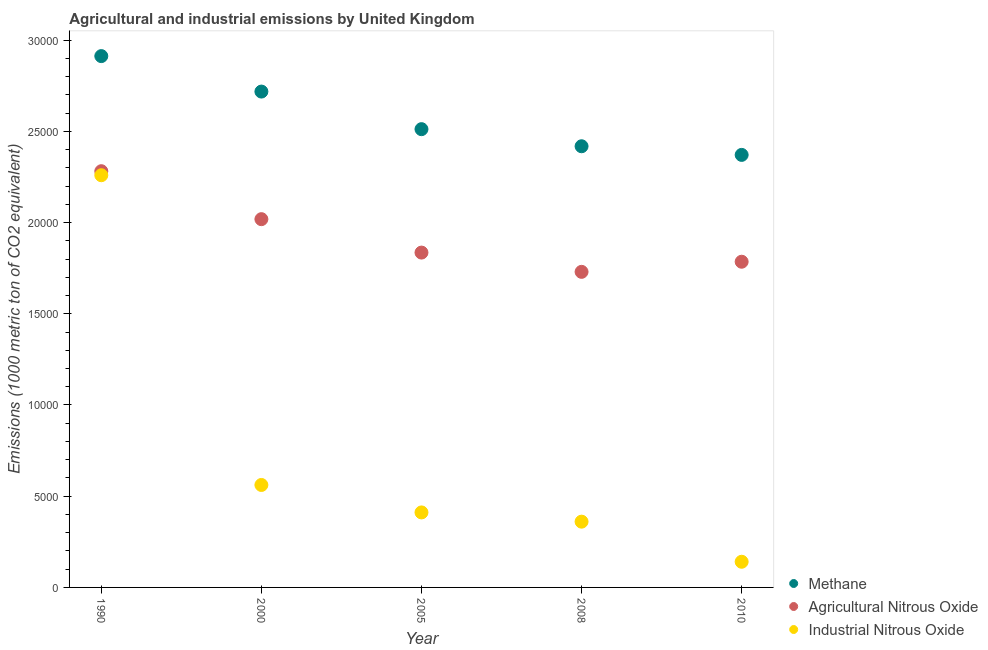What is the amount of methane emissions in 2005?
Give a very brief answer. 2.51e+04. Across all years, what is the maximum amount of methane emissions?
Provide a short and direct response. 2.91e+04. Across all years, what is the minimum amount of methane emissions?
Your answer should be very brief. 2.37e+04. What is the total amount of methane emissions in the graph?
Your answer should be compact. 1.29e+05. What is the difference between the amount of methane emissions in 1990 and that in 2008?
Ensure brevity in your answer.  4941.2. What is the difference between the amount of methane emissions in 2010 and the amount of industrial nitrous oxide emissions in 1990?
Your answer should be very brief. 1114.8. What is the average amount of agricultural nitrous oxide emissions per year?
Your answer should be compact. 1.93e+04. In the year 2000, what is the difference between the amount of industrial nitrous oxide emissions and amount of methane emissions?
Make the answer very short. -2.16e+04. In how many years, is the amount of industrial nitrous oxide emissions greater than 3000 metric ton?
Your answer should be compact. 4. What is the ratio of the amount of industrial nitrous oxide emissions in 2008 to that in 2010?
Offer a terse response. 2.56. Is the amount of agricultural nitrous oxide emissions in 2005 less than that in 2010?
Ensure brevity in your answer.  No. Is the difference between the amount of industrial nitrous oxide emissions in 2000 and 2008 greater than the difference between the amount of methane emissions in 2000 and 2008?
Keep it short and to the point. No. What is the difference between the highest and the second highest amount of agricultural nitrous oxide emissions?
Your response must be concise. 2628.9. What is the difference between the highest and the lowest amount of methane emissions?
Give a very brief answer. 5414.5. Is the sum of the amount of industrial nitrous oxide emissions in 2005 and 2010 greater than the maximum amount of agricultural nitrous oxide emissions across all years?
Offer a terse response. No. Is it the case that in every year, the sum of the amount of methane emissions and amount of agricultural nitrous oxide emissions is greater than the amount of industrial nitrous oxide emissions?
Your response must be concise. Yes. Does the amount of methane emissions monotonically increase over the years?
Offer a terse response. No. Is the amount of methane emissions strictly greater than the amount of industrial nitrous oxide emissions over the years?
Your answer should be very brief. Yes. Is the amount of methane emissions strictly less than the amount of industrial nitrous oxide emissions over the years?
Your answer should be very brief. No. How many dotlines are there?
Provide a succinct answer. 3. How many years are there in the graph?
Keep it short and to the point. 5. What is the difference between two consecutive major ticks on the Y-axis?
Provide a short and direct response. 5000. Does the graph contain any zero values?
Your answer should be compact. No. How many legend labels are there?
Make the answer very short. 3. What is the title of the graph?
Ensure brevity in your answer.  Agricultural and industrial emissions by United Kingdom. What is the label or title of the X-axis?
Offer a very short reply. Year. What is the label or title of the Y-axis?
Provide a short and direct response. Emissions (1000 metric ton of CO2 equivalent). What is the Emissions (1000 metric ton of CO2 equivalent) in Methane in 1990?
Your answer should be compact. 2.91e+04. What is the Emissions (1000 metric ton of CO2 equivalent) of Agricultural Nitrous Oxide in 1990?
Offer a terse response. 2.28e+04. What is the Emissions (1000 metric ton of CO2 equivalent) in Industrial Nitrous Oxide in 1990?
Offer a very short reply. 2.26e+04. What is the Emissions (1000 metric ton of CO2 equivalent) in Methane in 2000?
Ensure brevity in your answer.  2.72e+04. What is the Emissions (1000 metric ton of CO2 equivalent) of Agricultural Nitrous Oxide in 2000?
Offer a terse response. 2.02e+04. What is the Emissions (1000 metric ton of CO2 equivalent) of Industrial Nitrous Oxide in 2000?
Ensure brevity in your answer.  5616. What is the Emissions (1000 metric ton of CO2 equivalent) of Methane in 2005?
Provide a succinct answer. 2.51e+04. What is the Emissions (1000 metric ton of CO2 equivalent) of Agricultural Nitrous Oxide in 2005?
Your response must be concise. 1.84e+04. What is the Emissions (1000 metric ton of CO2 equivalent) in Industrial Nitrous Oxide in 2005?
Your response must be concise. 4111.2. What is the Emissions (1000 metric ton of CO2 equivalent) in Methane in 2008?
Your answer should be compact. 2.42e+04. What is the Emissions (1000 metric ton of CO2 equivalent) of Agricultural Nitrous Oxide in 2008?
Offer a terse response. 1.73e+04. What is the Emissions (1000 metric ton of CO2 equivalent) in Industrial Nitrous Oxide in 2008?
Provide a succinct answer. 3604.6. What is the Emissions (1000 metric ton of CO2 equivalent) in Methane in 2010?
Your answer should be compact. 2.37e+04. What is the Emissions (1000 metric ton of CO2 equivalent) of Agricultural Nitrous Oxide in 2010?
Your answer should be very brief. 1.79e+04. What is the Emissions (1000 metric ton of CO2 equivalent) in Industrial Nitrous Oxide in 2010?
Your answer should be very brief. 1406.6. Across all years, what is the maximum Emissions (1000 metric ton of CO2 equivalent) in Methane?
Your response must be concise. 2.91e+04. Across all years, what is the maximum Emissions (1000 metric ton of CO2 equivalent) in Agricultural Nitrous Oxide?
Your answer should be compact. 2.28e+04. Across all years, what is the maximum Emissions (1000 metric ton of CO2 equivalent) of Industrial Nitrous Oxide?
Offer a very short reply. 2.26e+04. Across all years, what is the minimum Emissions (1000 metric ton of CO2 equivalent) of Methane?
Give a very brief answer. 2.37e+04. Across all years, what is the minimum Emissions (1000 metric ton of CO2 equivalent) of Agricultural Nitrous Oxide?
Your answer should be compact. 1.73e+04. Across all years, what is the minimum Emissions (1000 metric ton of CO2 equivalent) in Industrial Nitrous Oxide?
Provide a short and direct response. 1406.6. What is the total Emissions (1000 metric ton of CO2 equivalent) of Methane in the graph?
Your answer should be compact. 1.29e+05. What is the total Emissions (1000 metric ton of CO2 equivalent) in Agricultural Nitrous Oxide in the graph?
Offer a very short reply. 9.65e+04. What is the total Emissions (1000 metric ton of CO2 equivalent) in Industrial Nitrous Oxide in the graph?
Keep it short and to the point. 3.73e+04. What is the difference between the Emissions (1000 metric ton of CO2 equivalent) in Methane in 1990 and that in 2000?
Keep it short and to the point. 1944.1. What is the difference between the Emissions (1000 metric ton of CO2 equivalent) of Agricultural Nitrous Oxide in 1990 and that in 2000?
Your answer should be very brief. 2628.9. What is the difference between the Emissions (1000 metric ton of CO2 equivalent) in Industrial Nitrous Oxide in 1990 and that in 2000?
Make the answer very short. 1.70e+04. What is the difference between the Emissions (1000 metric ton of CO2 equivalent) in Methane in 1990 and that in 2005?
Keep it short and to the point. 4004.1. What is the difference between the Emissions (1000 metric ton of CO2 equivalent) of Agricultural Nitrous Oxide in 1990 and that in 2005?
Make the answer very short. 4460.9. What is the difference between the Emissions (1000 metric ton of CO2 equivalent) of Industrial Nitrous Oxide in 1990 and that in 2005?
Your answer should be compact. 1.85e+04. What is the difference between the Emissions (1000 metric ton of CO2 equivalent) of Methane in 1990 and that in 2008?
Make the answer very short. 4941.2. What is the difference between the Emissions (1000 metric ton of CO2 equivalent) of Agricultural Nitrous Oxide in 1990 and that in 2008?
Your answer should be very brief. 5516.7. What is the difference between the Emissions (1000 metric ton of CO2 equivalent) in Industrial Nitrous Oxide in 1990 and that in 2008?
Keep it short and to the point. 1.90e+04. What is the difference between the Emissions (1000 metric ton of CO2 equivalent) in Methane in 1990 and that in 2010?
Your answer should be very brief. 5414.5. What is the difference between the Emissions (1000 metric ton of CO2 equivalent) in Agricultural Nitrous Oxide in 1990 and that in 2010?
Give a very brief answer. 4962.2. What is the difference between the Emissions (1000 metric ton of CO2 equivalent) in Industrial Nitrous Oxide in 1990 and that in 2010?
Ensure brevity in your answer.  2.12e+04. What is the difference between the Emissions (1000 metric ton of CO2 equivalent) in Methane in 2000 and that in 2005?
Offer a very short reply. 2060. What is the difference between the Emissions (1000 metric ton of CO2 equivalent) in Agricultural Nitrous Oxide in 2000 and that in 2005?
Offer a very short reply. 1832. What is the difference between the Emissions (1000 metric ton of CO2 equivalent) of Industrial Nitrous Oxide in 2000 and that in 2005?
Provide a short and direct response. 1504.8. What is the difference between the Emissions (1000 metric ton of CO2 equivalent) of Methane in 2000 and that in 2008?
Give a very brief answer. 2997.1. What is the difference between the Emissions (1000 metric ton of CO2 equivalent) in Agricultural Nitrous Oxide in 2000 and that in 2008?
Offer a very short reply. 2887.8. What is the difference between the Emissions (1000 metric ton of CO2 equivalent) of Industrial Nitrous Oxide in 2000 and that in 2008?
Make the answer very short. 2011.4. What is the difference between the Emissions (1000 metric ton of CO2 equivalent) in Methane in 2000 and that in 2010?
Keep it short and to the point. 3470.4. What is the difference between the Emissions (1000 metric ton of CO2 equivalent) in Agricultural Nitrous Oxide in 2000 and that in 2010?
Provide a succinct answer. 2333.3. What is the difference between the Emissions (1000 metric ton of CO2 equivalent) in Industrial Nitrous Oxide in 2000 and that in 2010?
Provide a short and direct response. 4209.4. What is the difference between the Emissions (1000 metric ton of CO2 equivalent) in Methane in 2005 and that in 2008?
Offer a very short reply. 937.1. What is the difference between the Emissions (1000 metric ton of CO2 equivalent) in Agricultural Nitrous Oxide in 2005 and that in 2008?
Offer a very short reply. 1055.8. What is the difference between the Emissions (1000 metric ton of CO2 equivalent) of Industrial Nitrous Oxide in 2005 and that in 2008?
Give a very brief answer. 506.6. What is the difference between the Emissions (1000 metric ton of CO2 equivalent) of Methane in 2005 and that in 2010?
Make the answer very short. 1410.4. What is the difference between the Emissions (1000 metric ton of CO2 equivalent) in Agricultural Nitrous Oxide in 2005 and that in 2010?
Make the answer very short. 501.3. What is the difference between the Emissions (1000 metric ton of CO2 equivalent) of Industrial Nitrous Oxide in 2005 and that in 2010?
Your response must be concise. 2704.6. What is the difference between the Emissions (1000 metric ton of CO2 equivalent) in Methane in 2008 and that in 2010?
Your answer should be very brief. 473.3. What is the difference between the Emissions (1000 metric ton of CO2 equivalent) in Agricultural Nitrous Oxide in 2008 and that in 2010?
Provide a succinct answer. -554.5. What is the difference between the Emissions (1000 metric ton of CO2 equivalent) of Industrial Nitrous Oxide in 2008 and that in 2010?
Provide a short and direct response. 2198. What is the difference between the Emissions (1000 metric ton of CO2 equivalent) of Methane in 1990 and the Emissions (1000 metric ton of CO2 equivalent) of Agricultural Nitrous Oxide in 2000?
Your answer should be compact. 8937.3. What is the difference between the Emissions (1000 metric ton of CO2 equivalent) in Methane in 1990 and the Emissions (1000 metric ton of CO2 equivalent) in Industrial Nitrous Oxide in 2000?
Provide a succinct answer. 2.35e+04. What is the difference between the Emissions (1000 metric ton of CO2 equivalent) of Agricultural Nitrous Oxide in 1990 and the Emissions (1000 metric ton of CO2 equivalent) of Industrial Nitrous Oxide in 2000?
Ensure brevity in your answer.  1.72e+04. What is the difference between the Emissions (1000 metric ton of CO2 equivalent) of Methane in 1990 and the Emissions (1000 metric ton of CO2 equivalent) of Agricultural Nitrous Oxide in 2005?
Offer a very short reply. 1.08e+04. What is the difference between the Emissions (1000 metric ton of CO2 equivalent) of Methane in 1990 and the Emissions (1000 metric ton of CO2 equivalent) of Industrial Nitrous Oxide in 2005?
Provide a succinct answer. 2.50e+04. What is the difference between the Emissions (1000 metric ton of CO2 equivalent) in Agricultural Nitrous Oxide in 1990 and the Emissions (1000 metric ton of CO2 equivalent) in Industrial Nitrous Oxide in 2005?
Offer a very short reply. 1.87e+04. What is the difference between the Emissions (1000 metric ton of CO2 equivalent) in Methane in 1990 and the Emissions (1000 metric ton of CO2 equivalent) in Agricultural Nitrous Oxide in 2008?
Give a very brief answer. 1.18e+04. What is the difference between the Emissions (1000 metric ton of CO2 equivalent) in Methane in 1990 and the Emissions (1000 metric ton of CO2 equivalent) in Industrial Nitrous Oxide in 2008?
Your answer should be compact. 2.55e+04. What is the difference between the Emissions (1000 metric ton of CO2 equivalent) in Agricultural Nitrous Oxide in 1990 and the Emissions (1000 metric ton of CO2 equivalent) in Industrial Nitrous Oxide in 2008?
Your answer should be compact. 1.92e+04. What is the difference between the Emissions (1000 metric ton of CO2 equivalent) of Methane in 1990 and the Emissions (1000 metric ton of CO2 equivalent) of Agricultural Nitrous Oxide in 2010?
Keep it short and to the point. 1.13e+04. What is the difference between the Emissions (1000 metric ton of CO2 equivalent) of Methane in 1990 and the Emissions (1000 metric ton of CO2 equivalent) of Industrial Nitrous Oxide in 2010?
Your answer should be very brief. 2.77e+04. What is the difference between the Emissions (1000 metric ton of CO2 equivalent) in Agricultural Nitrous Oxide in 1990 and the Emissions (1000 metric ton of CO2 equivalent) in Industrial Nitrous Oxide in 2010?
Offer a terse response. 2.14e+04. What is the difference between the Emissions (1000 metric ton of CO2 equivalent) of Methane in 2000 and the Emissions (1000 metric ton of CO2 equivalent) of Agricultural Nitrous Oxide in 2005?
Make the answer very short. 8825.2. What is the difference between the Emissions (1000 metric ton of CO2 equivalent) of Methane in 2000 and the Emissions (1000 metric ton of CO2 equivalent) of Industrial Nitrous Oxide in 2005?
Provide a succinct answer. 2.31e+04. What is the difference between the Emissions (1000 metric ton of CO2 equivalent) of Agricultural Nitrous Oxide in 2000 and the Emissions (1000 metric ton of CO2 equivalent) of Industrial Nitrous Oxide in 2005?
Your response must be concise. 1.61e+04. What is the difference between the Emissions (1000 metric ton of CO2 equivalent) in Methane in 2000 and the Emissions (1000 metric ton of CO2 equivalent) in Agricultural Nitrous Oxide in 2008?
Keep it short and to the point. 9881. What is the difference between the Emissions (1000 metric ton of CO2 equivalent) in Methane in 2000 and the Emissions (1000 metric ton of CO2 equivalent) in Industrial Nitrous Oxide in 2008?
Give a very brief answer. 2.36e+04. What is the difference between the Emissions (1000 metric ton of CO2 equivalent) in Agricultural Nitrous Oxide in 2000 and the Emissions (1000 metric ton of CO2 equivalent) in Industrial Nitrous Oxide in 2008?
Ensure brevity in your answer.  1.66e+04. What is the difference between the Emissions (1000 metric ton of CO2 equivalent) in Methane in 2000 and the Emissions (1000 metric ton of CO2 equivalent) in Agricultural Nitrous Oxide in 2010?
Provide a succinct answer. 9326.5. What is the difference between the Emissions (1000 metric ton of CO2 equivalent) in Methane in 2000 and the Emissions (1000 metric ton of CO2 equivalent) in Industrial Nitrous Oxide in 2010?
Ensure brevity in your answer.  2.58e+04. What is the difference between the Emissions (1000 metric ton of CO2 equivalent) of Agricultural Nitrous Oxide in 2000 and the Emissions (1000 metric ton of CO2 equivalent) of Industrial Nitrous Oxide in 2010?
Ensure brevity in your answer.  1.88e+04. What is the difference between the Emissions (1000 metric ton of CO2 equivalent) in Methane in 2005 and the Emissions (1000 metric ton of CO2 equivalent) in Agricultural Nitrous Oxide in 2008?
Provide a succinct answer. 7821. What is the difference between the Emissions (1000 metric ton of CO2 equivalent) of Methane in 2005 and the Emissions (1000 metric ton of CO2 equivalent) of Industrial Nitrous Oxide in 2008?
Your answer should be compact. 2.15e+04. What is the difference between the Emissions (1000 metric ton of CO2 equivalent) of Agricultural Nitrous Oxide in 2005 and the Emissions (1000 metric ton of CO2 equivalent) of Industrial Nitrous Oxide in 2008?
Provide a short and direct response. 1.47e+04. What is the difference between the Emissions (1000 metric ton of CO2 equivalent) in Methane in 2005 and the Emissions (1000 metric ton of CO2 equivalent) in Agricultural Nitrous Oxide in 2010?
Keep it short and to the point. 7266.5. What is the difference between the Emissions (1000 metric ton of CO2 equivalent) of Methane in 2005 and the Emissions (1000 metric ton of CO2 equivalent) of Industrial Nitrous Oxide in 2010?
Offer a terse response. 2.37e+04. What is the difference between the Emissions (1000 metric ton of CO2 equivalent) in Agricultural Nitrous Oxide in 2005 and the Emissions (1000 metric ton of CO2 equivalent) in Industrial Nitrous Oxide in 2010?
Offer a very short reply. 1.69e+04. What is the difference between the Emissions (1000 metric ton of CO2 equivalent) in Methane in 2008 and the Emissions (1000 metric ton of CO2 equivalent) in Agricultural Nitrous Oxide in 2010?
Offer a very short reply. 6329.4. What is the difference between the Emissions (1000 metric ton of CO2 equivalent) of Methane in 2008 and the Emissions (1000 metric ton of CO2 equivalent) of Industrial Nitrous Oxide in 2010?
Keep it short and to the point. 2.28e+04. What is the difference between the Emissions (1000 metric ton of CO2 equivalent) of Agricultural Nitrous Oxide in 2008 and the Emissions (1000 metric ton of CO2 equivalent) of Industrial Nitrous Oxide in 2010?
Make the answer very short. 1.59e+04. What is the average Emissions (1000 metric ton of CO2 equivalent) of Methane per year?
Your response must be concise. 2.59e+04. What is the average Emissions (1000 metric ton of CO2 equivalent) in Agricultural Nitrous Oxide per year?
Your response must be concise. 1.93e+04. What is the average Emissions (1000 metric ton of CO2 equivalent) in Industrial Nitrous Oxide per year?
Keep it short and to the point. 7466.28. In the year 1990, what is the difference between the Emissions (1000 metric ton of CO2 equivalent) of Methane and Emissions (1000 metric ton of CO2 equivalent) of Agricultural Nitrous Oxide?
Make the answer very short. 6308.4. In the year 1990, what is the difference between the Emissions (1000 metric ton of CO2 equivalent) in Methane and Emissions (1000 metric ton of CO2 equivalent) in Industrial Nitrous Oxide?
Offer a very short reply. 6529.3. In the year 1990, what is the difference between the Emissions (1000 metric ton of CO2 equivalent) of Agricultural Nitrous Oxide and Emissions (1000 metric ton of CO2 equivalent) of Industrial Nitrous Oxide?
Offer a very short reply. 220.9. In the year 2000, what is the difference between the Emissions (1000 metric ton of CO2 equivalent) in Methane and Emissions (1000 metric ton of CO2 equivalent) in Agricultural Nitrous Oxide?
Offer a terse response. 6993.2. In the year 2000, what is the difference between the Emissions (1000 metric ton of CO2 equivalent) of Methane and Emissions (1000 metric ton of CO2 equivalent) of Industrial Nitrous Oxide?
Keep it short and to the point. 2.16e+04. In the year 2000, what is the difference between the Emissions (1000 metric ton of CO2 equivalent) of Agricultural Nitrous Oxide and Emissions (1000 metric ton of CO2 equivalent) of Industrial Nitrous Oxide?
Provide a succinct answer. 1.46e+04. In the year 2005, what is the difference between the Emissions (1000 metric ton of CO2 equivalent) of Methane and Emissions (1000 metric ton of CO2 equivalent) of Agricultural Nitrous Oxide?
Provide a succinct answer. 6765.2. In the year 2005, what is the difference between the Emissions (1000 metric ton of CO2 equivalent) of Methane and Emissions (1000 metric ton of CO2 equivalent) of Industrial Nitrous Oxide?
Your response must be concise. 2.10e+04. In the year 2005, what is the difference between the Emissions (1000 metric ton of CO2 equivalent) of Agricultural Nitrous Oxide and Emissions (1000 metric ton of CO2 equivalent) of Industrial Nitrous Oxide?
Make the answer very short. 1.42e+04. In the year 2008, what is the difference between the Emissions (1000 metric ton of CO2 equivalent) of Methane and Emissions (1000 metric ton of CO2 equivalent) of Agricultural Nitrous Oxide?
Provide a succinct answer. 6883.9. In the year 2008, what is the difference between the Emissions (1000 metric ton of CO2 equivalent) of Methane and Emissions (1000 metric ton of CO2 equivalent) of Industrial Nitrous Oxide?
Your answer should be compact. 2.06e+04. In the year 2008, what is the difference between the Emissions (1000 metric ton of CO2 equivalent) of Agricultural Nitrous Oxide and Emissions (1000 metric ton of CO2 equivalent) of Industrial Nitrous Oxide?
Ensure brevity in your answer.  1.37e+04. In the year 2010, what is the difference between the Emissions (1000 metric ton of CO2 equivalent) in Methane and Emissions (1000 metric ton of CO2 equivalent) in Agricultural Nitrous Oxide?
Your answer should be very brief. 5856.1. In the year 2010, what is the difference between the Emissions (1000 metric ton of CO2 equivalent) in Methane and Emissions (1000 metric ton of CO2 equivalent) in Industrial Nitrous Oxide?
Give a very brief answer. 2.23e+04. In the year 2010, what is the difference between the Emissions (1000 metric ton of CO2 equivalent) in Agricultural Nitrous Oxide and Emissions (1000 metric ton of CO2 equivalent) in Industrial Nitrous Oxide?
Keep it short and to the point. 1.64e+04. What is the ratio of the Emissions (1000 metric ton of CO2 equivalent) of Methane in 1990 to that in 2000?
Ensure brevity in your answer.  1.07. What is the ratio of the Emissions (1000 metric ton of CO2 equivalent) in Agricultural Nitrous Oxide in 1990 to that in 2000?
Provide a succinct answer. 1.13. What is the ratio of the Emissions (1000 metric ton of CO2 equivalent) in Industrial Nitrous Oxide in 1990 to that in 2000?
Make the answer very short. 4.02. What is the ratio of the Emissions (1000 metric ton of CO2 equivalent) in Methane in 1990 to that in 2005?
Offer a very short reply. 1.16. What is the ratio of the Emissions (1000 metric ton of CO2 equivalent) of Agricultural Nitrous Oxide in 1990 to that in 2005?
Provide a succinct answer. 1.24. What is the ratio of the Emissions (1000 metric ton of CO2 equivalent) of Industrial Nitrous Oxide in 1990 to that in 2005?
Keep it short and to the point. 5.5. What is the ratio of the Emissions (1000 metric ton of CO2 equivalent) of Methane in 1990 to that in 2008?
Ensure brevity in your answer.  1.2. What is the ratio of the Emissions (1000 metric ton of CO2 equivalent) of Agricultural Nitrous Oxide in 1990 to that in 2008?
Provide a succinct answer. 1.32. What is the ratio of the Emissions (1000 metric ton of CO2 equivalent) in Industrial Nitrous Oxide in 1990 to that in 2008?
Your answer should be very brief. 6.27. What is the ratio of the Emissions (1000 metric ton of CO2 equivalent) of Methane in 1990 to that in 2010?
Provide a short and direct response. 1.23. What is the ratio of the Emissions (1000 metric ton of CO2 equivalent) of Agricultural Nitrous Oxide in 1990 to that in 2010?
Ensure brevity in your answer.  1.28. What is the ratio of the Emissions (1000 metric ton of CO2 equivalent) in Industrial Nitrous Oxide in 1990 to that in 2010?
Provide a short and direct response. 16.06. What is the ratio of the Emissions (1000 metric ton of CO2 equivalent) in Methane in 2000 to that in 2005?
Offer a terse response. 1.08. What is the ratio of the Emissions (1000 metric ton of CO2 equivalent) of Agricultural Nitrous Oxide in 2000 to that in 2005?
Ensure brevity in your answer.  1.1. What is the ratio of the Emissions (1000 metric ton of CO2 equivalent) in Industrial Nitrous Oxide in 2000 to that in 2005?
Keep it short and to the point. 1.37. What is the ratio of the Emissions (1000 metric ton of CO2 equivalent) in Methane in 2000 to that in 2008?
Your answer should be very brief. 1.12. What is the ratio of the Emissions (1000 metric ton of CO2 equivalent) in Agricultural Nitrous Oxide in 2000 to that in 2008?
Your answer should be very brief. 1.17. What is the ratio of the Emissions (1000 metric ton of CO2 equivalent) of Industrial Nitrous Oxide in 2000 to that in 2008?
Give a very brief answer. 1.56. What is the ratio of the Emissions (1000 metric ton of CO2 equivalent) in Methane in 2000 to that in 2010?
Your answer should be very brief. 1.15. What is the ratio of the Emissions (1000 metric ton of CO2 equivalent) in Agricultural Nitrous Oxide in 2000 to that in 2010?
Keep it short and to the point. 1.13. What is the ratio of the Emissions (1000 metric ton of CO2 equivalent) in Industrial Nitrous Oxide in 2000 to that in 2010?
Ensure brevity in your answer.  3.99. What is the ratio of the Emissions (1000 metric ton of CO2 equivalent) of Methane in 2005 to that in 2008?
Your answer should be very brief. 1.04. What is the ratio of the Emissions (1000 metric ton of CO2 equivalent) in Agricultural Nitrous Oxide in 2005 to that in 2008?
Keep it short and to the point. 1.06. What is the ratio of the Emissions (1000 metric ton of CO2 equivalent) in Industrial Nitrous Oxide in 2005 to that in 2008?
Your response must be concise. 1.14. What is the ratio of the Emissions (1000 metric ton of CO2 equivalent) in Methane in 2005 to that in 2010?
Ensure brevity in your answer.  1.06. What is the ratio of the Emissions (1000 metric ton of CO2 equivalent) in Agricultural Nitrous Oxide in 2005 to that in 2010?
Ensure brevity in your answer.  1.03. What is the ratio of the Emissions (1000 metric ton of CO2 equivalent) of Industrial Nitrous Oxide in 2005 to that in 2010?
Keep it short and to the point. 2.92. What is the ratio of the Emissions (1000 metric ton of CO2 equivalent) in Agricultural Nitrous Oxide in 2008 to that in 2010?
Your answer should be compact. 0.97. What is the ratio of the Emissions (1000 metric ton of CO2 equivalent) in Industrial Nitrous Oxide in 2008 to that in 2010?
Make the answer very short. 2.56. What is the difference between the highest and the second highest Emissions (1000 metric ton of CO2 equivalent) in Methane?
Provide a short and direct response. 1944.1. What is the difference between the highest and the second highest Emissions (1000 metric ton of CO2 equivalent) in Agricultural Nitrous Oxide?
Your response must be concise. 2628.9. What is the difference between the highest and the second highest Emissions (1000 metric ton of CO2 equivalent) in Industrial Nitrous Oxide?
Give a very brief answer. 1.70e+04. What is the difference between the highest and the lowest Emissions (1000 metric ton of CO2 equivalent) of Methane?
Make the answer very short. 5414.5. What is the difference between the highest and the lowest Emissions (1000 metric ton of CO2 equivalent) of Agricultural Nitrous Oxide?
Your answer should be very brief. 5516.7. What is the difference between the highest and the lowest Emissions (1000 metric ton of CO2 equivalent) of Industrial Nitrous Oxide?
Ensure brevity in your answer.  2.12e+04. 